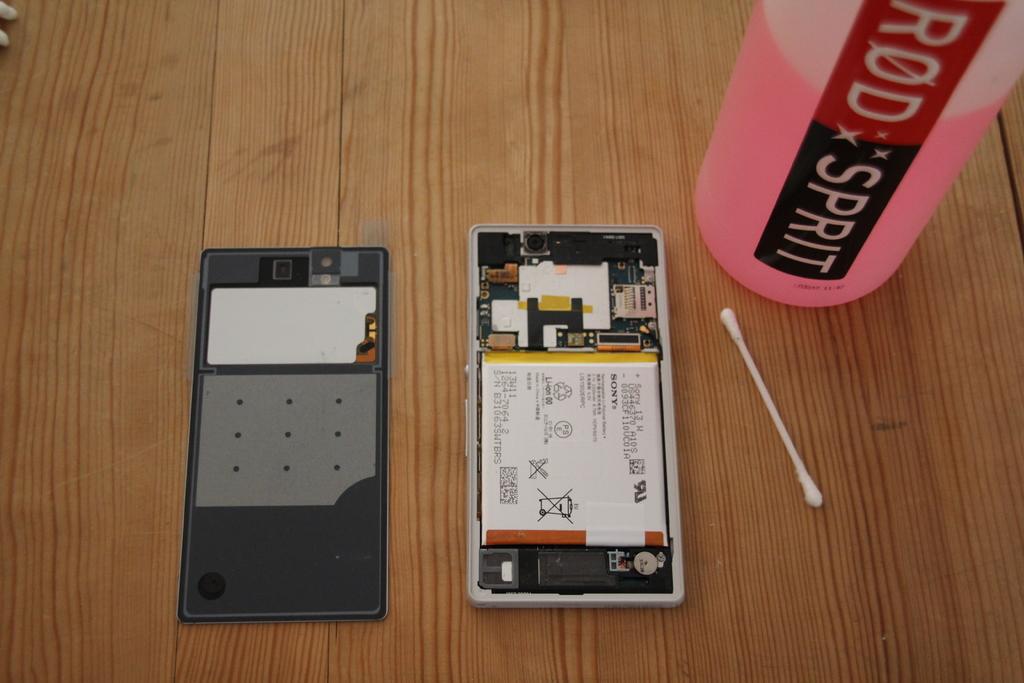Is the image on the phone a prescription?
Your response must be concise. Unanswerable. What is in the bottle?
Provide a succinct answer. Rod sprit. 